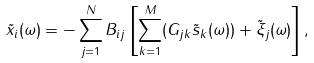<formula> <loc_0><loc_0><loc_500><loc_500>\tilde { x } _ { i } ( \omega ) = - \sum _ { j = 1 } ^ { N } B _ { i j } \left [ \sum _ { k = 1 } ^ { M } ( G _ { j k } \tilde { s } _ { k } ( \omega ) ) + \tilde { \xi } _ { j } ( \omega ) \right ] ,</formula> 